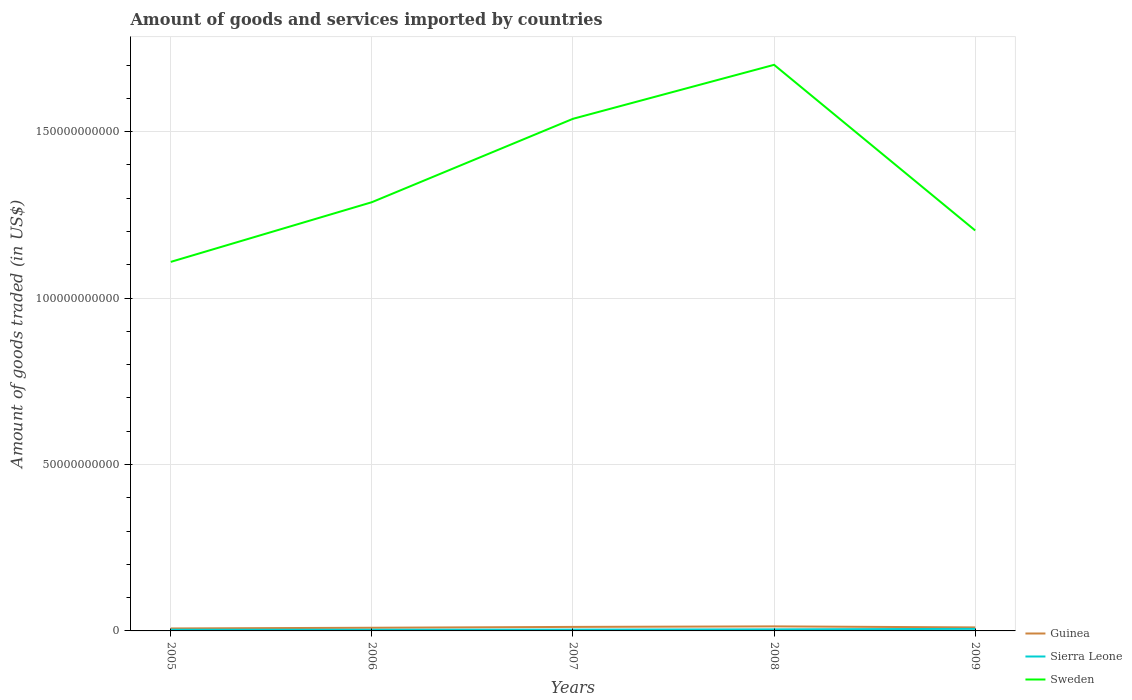How many different coloured lines are there?
Your response must be concise. 3. Does the line corresponding to Sweden intersect with the line corresponding to Guinea?
Make the answer very short. No. Is the number of lines equal to the number of legend labels?
Ensure brevity in your answer.  Yes. Across all years, what is the maximum total amount of goods and services imported in Sierra Leone?
Provide a short and direct response. 3.51e+08. In which year was the total amount of goods and services imported in Guinea maximum?
Give a very brief answer. 2005. What is the total total amount of goods and services imported in Guinea in the graph?
Keep it short and to the point. 3.10e+08. What is the difference between the highest and the second highest total amount of goods and services imported in Sweden?
Make the answer very short. 5.92e+1. What is the difference between the highest and the lowest total amount of goods and services imported in Guinea?
Your answer should be very brief. 2. Is the total amount of goods and services imported in Sweden strictly greater than the total amount of goods and services imported in Sierra Leone over the years?
Offer a terse response. No. What is the difference between two consecutive major ticks on the Y-axis?
Offer a very short reply. 5.00e+1. Does the graph contain any zero values?
Give a very brief answer. No. Does the graph contain grids?
Provide a succinct answer. Yes. Where does the legend appear in the graph?
Make the answer very short. Bottom right. How many legend labels are there?
Provide a short and direct response. 3. What is the title of the graph?
Ensure brevity in your answer.  Amount of goods and services imported by countries. What is the label or title of the Y-axis?
Offer a very short reply. Amount of goods traded (in US$). What is the Amount of goods traded (in US$) in Guinea in 2005?
Provide a succinct answer. 7.40e+08. What is the Amount of goods traded (in US$) of Sierra Leone in 2005?
Offer a terse response. 3.62e+08. What is the Amount of goods traded (in US$) in Sweden in 2005?
Your answer should be very brief. 1.11e+11. What is the Amount of goods traded (in US$) of Guinea in 2006?
Make the answer very short. 9.51e+08. What is the Amount of goods traded (in US$) of Sierra Leone in 2006?
Make the answer very short. 3.51e+08. What is the Amount of goods traded (in US$) of Sweden in 2006?
Your answer should be compact. 1.29e+11. What is the Amount of goods traded (in US$) of Guinea in 2007?
Ensure brevity in your answer.  1.21e+09. What is the Amount of goods traded (in US$) of Sierra Leone in 2007?
Ensure brevity in your answer.  3.95e+08. What is the Amount of goods traded (in US$) of Sweden in 2007?
Keep it short and to the point. 1.54e+11. What is the Amount of goods traded (in US$) in Guinea in 2008?
Offer a terse response. 1.36e+09. What is the Amount of goods traded (in US$) of Sierra Leone in 2008?
Give a very brief answer. 4.71e+08. What is the Amount of goods traded (in US$) of Sweden in 2008?
Provide a succinct answer. 1.70e+11. What is the Amount of goods traded (in US$) of Guinea in 2009?
Ensure brevity in your answer.  1.05e+09. What is the Amount of goods traded (in US$) of Sierra Leone in 2009?
Your answer should be compact. 6.18e+08. What is the Amount of goods traded (in US$) of Sweden in 2009?
Your answer should be compact. 1.20e+11. Across all years, what is the maximum Amount of goods traded (in US$) of Guinea?
Offer a very short reply. 1.36e+09. Across all years, what is the maximum Amount of goods traded (in US$) in Sierra Leone?
Ensure brevity in your answer.  6.18e+08. Across all years, what is the maximum Amount of goods traded (in US$) in Sweden?
Give a very brief answer. 1.70e+11. Across all years, what is the minimum Amount of goods traded (in US$) of Guinea?
Give a very brief answer. 7.40e+08. Across all years, what is the minimum Amount of goods traded (in US$) in Sierra Leone?
Offer a very short reply. 3.51e+08. Across all years, what is the minimum Amount of goods traded (in US$) of Sweden?
Your answer should be very brief. 1.11e+11. What is the total Amount of goods traded (in US$) in Guinea in the graph?
Provide a succinct answer. 5.32e+09. What is the total Amount of goods traded (in US$) in Sierra Leone in the graph?
Your answer should be compact. 2.20e+09. What is the total Amount of goods traded (in US$) in Sweden in the graph?
Keep it short and to the point. 6.84e+11. What is the difference between the Amount of goods traded (in US$) of Guinea in 2005 and that in 2006?
Provide a succinct answer. -2.11e+08. What is the difference between the Amount of goods traded (in US$) in Sierra Leone in 2005 and that in 2006?
Your answer should be very brief. 1.05e+07. What is the difference between the Amount of goods traded (in US$) in Sweden in 2005 and that in 2006?
Provide a short and direct response. -1.79e+1. What is the difference between the Amount of goods traded (in US$) in Guinea in 2005 and that in 2007?
Your answer should be compact. -4.67e+08. What is the difference between the Amount of goods traded (in US$) of Sierra Leone in 2005 and that in 2007?
Make the answer very short. -3.38e+07. What is the difference between the Amount of goods traded (in US$) in Sweden in 2005 and that in 2007?
Offer a very short reply. -4.30e+1. What is the difference between the Amount of goods traded (in US$) in Guinea in 2005 and that in 2008?
Provide a short and direct response. -6.25e+08. What is the difference between the Amount of goods traded (in US$) of Sierra Leone in 2005 and that in 2008?
Your answer should be very brief. -1.10e+08. What is the difference between the Amount of goods traded (in US$) of Sweden in 2005 and that in 2008?
Provide a succinct answer. -5.92e+1. What is the difference between the Amount of goods traded (in US$) of Guinea in 2005 and that in 2009?
Provide a succinct answer. -3.15e+08. What is the difference between the Amount of goods traded (in US$) in Sierra Leone in 2005 and that in 2009?
Your answer should be very brief. -2.56e+08. What is the difference between the Amount of goods traded (in US$) in Sweden in 2005 and that in 2009?
Offer a terse response. -9.44e+09. What is the difference between the Amount of goods traded (in US$) in Guinea in 2006 and that in 2007?
Your answer should be very brief. -2.56e+08. What is the difference between the Amount of goods traded (in US$) in Sierra Leone in 2006 and that in 2007?
Make the answer very short. -4.43e+07. What is the difference between the Amount of goods traded (in US$) of Sweden in 2006 and that in 2007?
Give a very brief answer. -2.51e+1. What is the difference between the Amount of goods traded (in US$) of Guinea in 2006 and that in 2008?
Offer a very short reply. -4.14e+08. What is the difference between the Amount of goods traded (in US$) of Sierra Leone in 2006 and that in 2008?
Provide a succinct answer. -1.20e+08. What is the difference between the Amount of goods traded (in US$) of Sweden in 2006 and that in 2008?
Ensure brevity in your answer.  -4.13e+1. What is the difference between the Amount of goods traded (in US$) in Guinea in 2006 and that in 2009?
Provide a short and direct response. -1.04e+08. What is the difference between the Amount of goods traded (in US$) of Sierra Leone in 2006 and that in 2009?
Offer a very short reply. -2.66e+08. What is the difference between the Amount of goods traded (in US$) of Sweden in 2006 and that in 2009?
Keep it short and to the point. 8.50e+09. What is the difference between the Amount of goods traded (in US$) of Guinea in 2007 and that in 2008?
Keep it short and to the point. -1.58e+08. What is the difference between the Amount of goods traded (in US$) of Sierra Leone in 2007 and that in 2008?
Your answer should be very brief. -7.58e+07. What is the difference between the Amount of goods traded (in US$) in Sweden in 2007 and that in 2008?
Offer a very short reply. -1.62e+1. What is the difference between the Amount of goods traded (in US$) in Guinea in 2007 and that in 2009?
Provide a short and direct response. 1.52e+08. What is the difference between the Amount of goods traded (in US$) in Sierra Leone in 2007 and that in 2009?
Give a very brief answer. -2.22e+08. What is the difference between the Amount of goods traded (in US$) of Sweden in 2007 and that in 2009?
Give a very brief answer. 3.36e+1. What is the difference between the Amount of goods traded (in US$) of Guinea in 2008 and that in 2009?
Your response must be concise. 3.10e+08. What is the difference between the Amount of goods traded (in US$) in Sierra Leone in 2008 and that in 2009?
Your response must be concise. -1.46e+08. What is the difference between the Amount of goods traded (in US$) of Sweden in 2008 and that in 2009?
Keep it short and to the point. 4.98e+1. What is the difference between the Amount of goods traded (in US$) of Guinea in 2005 and the Amount of goods traded (in US$) of Sierra Leone in 2006?
Provide a short and direct response. 3.88e+08. What is the difference between the Amount of goods traded (in US$) in Guinea in 2005 and the Amount of goods traded (in US$) in Sweden in 2006?
Provide a short and direct response. -1.28e+11. What is the difference between the Amount of goods traded (in US$) of Sierra Leone in 2005 and the Amount of goods traded (in US$) of Sweden in 2006?
Make the answer very short. -1.28e+11. What is the difference between the Amount of goods traded (in US$) in Guinea in 2005 and the Amount of goods traded (in US$) in Sierra Leone in 2007?
Make the answer very short. 3.44e+08. What is the difference between the Amount of goods traded (in US$) in Guinea in 2005 and the Amount of goods traded (in US$) in Sweden in 2007?
Your answer should be very brief. -1.53e+11. What is the difference between the Amount of goods traded (in US$) of Sierra Leone in 2005 and the Amount of goods traded (in US$) of Sweden in 2007?
Keep it short and to the point. -1.53e+11. What is the difference between the Amount of goods traded (in US$) in Guinea in 2005 and the Amount of goods traded (in US$) in Sierra Leone in 2008?
Your response must be concise. 2.68e+08. What is the difference between the Amount of goods traded (in US$) in Guinea in 2005 and the Amount of goods traded (in US$) in Sweden in 2008?
Offer a terse response. -1.69e+11. What is the difference between the Amount of goods traded (in US$) of Sierra Leone in 2005 and the Amount of goods traded (in US$) of Sweden in 2008?
Keep it short and to the point. -1.70e+11. What is the difference between the Amount of goods traded (in US$) in Guinea in 2005 and the Amount of goods traded (in US$) in Sierra Leone in 2009?
Offer a terse response. 1.22e+08. What is the difference between the Amount of goods traded (in US$) of Guinea in 2005 and the Amount of goods traded (in US$) of Sweden in 2009?
Make the answer very short. -1.20e+11. What is the difference between the Amount of goods traded (in US$) in Sierra Leone in 2005 and the Amount of goods traded (in US$) in Sweden in 2009?
Offer a terse response. -1.20e+11. What is the difference between the Amount of goods traded (in US$) in Guinea in 2006 and the Amount of goods traded (in US$) in Sierra Leone in 2007?
Offer a terse response. 5.55e+08. What is the difference between the Amount of goods traded (in US$) in Guinea in 2006 and the Amount of goods traded (in US$) in Sweden in 2007?
Make the answer very short. -1.53e+11. What is the difference between the Amount of goods traded (in US$) of Sierra Leone in 2006 and the Amount of goods traded (in US$) of Sweden in 2007?
Give a very brief answer. -1.53e+11. What is the difference between the Amount of goods traded (in US$) of Guinea in 2006 and the Amount of goods traded (in US$) of Sierra Leone in 2008?
Give a very brief answer. 4.79e+08. What is the difference between the Amount of goods traded (in US$) of Guinea in 2006 and the Amount of goods traded (in US$) of Sweden in 2008?
Your answer should be very brief. -1.69e+11. What is the difference between the Amount of goods traded (in US$) in Sierra Leone in 2006 and the Amount of goods traded (in US$) in Sweden in 2008?
Keep it short and to the point. -1.70e+11. What is the difference between the Amount of goods traded (in US$) of Guinea in 2006 and the Amount of goods traded (in US$) of Sierra Leone in 2009?
Your answer should be compact. 3.33e+08. What is the difference between the Amount of goods traded (in US$) of Guinea in 2006 and the Amount of goods traded (in US$) of Sweden in 2009?
Your answer should be compact. -1.19e+11. What is the difference between the Amount of goods traded (in US$) in Sierra Leone in 2006 and the Amount of goods traded (in US$) in Sweden in 2009?
Give a very brief answer. -1.20e+11. What is the difference between the Amount of goods traded (in US$) in Guinea in 2007 and the Amount of goods traded (in US$) in Sierra Leone in 2008?
Your answer should be very brief. 7.35e+08. What is the difference between the Amount of goods traded (in US$) of Guinea in 2007 and the Amount of goods traded (in US$) of Sweden in 2008?
Provide a succinct answer. -1.69e+11. What is the difference between the Amount of goods traded (in US$) in Sierra Leone in 2007 and the Amount of goods traded (in US$) in Sweden in 2008?
Your answer should be very brief. -1.70e+11. What is the difference between the Amount of goods traded (in US$) in Guinea in 2007 and the Amount of goods traded (in US$) in Sierra Leone in 2009?
Your response must be concise. 5.89e+08. What is the difference between the Amount of goods traded (in US$) in Guinea in 2007 and the Amount of goods traded (in US$) in Sweden in 2009?
Provide a succinct answer. -1.19e+11. What is the difference between the Amount of goods traded (in US$) of Sierra Leone in 2007 and the Amount of goods traded (in US$) of Sweden in 2009?
Ensure brevity in your answer.  -1.20e+11. What is the difference between the Amount of goods traded (in US$) in Guinea in 2008 and the Amount of goods traded (in US$) in Sierra Leone in 2009?
Your answer should be very brief. 7.47e+08. What is the difference between the Amount of goods traded (in US$) in Guinea in 2008 and the Amount of goods traded (in US$) in Sweden in 2009?
Offer a terse response. -1.19e+11. What is the difference between the Amount of goods traded (in US$) of Sierra Leone in 2008 and the Amount of goods traded (in US$) of Sweden in 2009?
Provide a short and direct response. -1.20e+11. What is the average Amount of goods traded (in US$) in Guinea per year?
Provide a succinct answer. 1.06e+09. What is the average Amount of goods traded (in US$) of Sierra Leone per year?
Offer a terse response. 4.39e+08. What is the average Amount of goods traded (in US$) of Sweden per year?
Your answer should be compact. 1.37e+11. In the year 2005, what is the difference between the Amount of goods traded (in US$) in Guinea and Amount of goods traded (in US$) in Sierra Leone?
Give a very brief answer. 3.78e+08. In the year 2005, what is the difference between the Amount of goods traded (in US$) of Guinea and Amount of goods traded (in US$) of Sweden?
Ensure brevity in your answer.  -1.10e+11. In the year 2005, what is the difference between the Amount of goods traded (in US$) in Sierra Leone and Amount of goods traded (in US$) in Sweden?
Provide a short and direct response. -1.10e+11. In the year 2006, what is the difference between the Amount of goods traded (in US$) in Guinea and Amount of goods traded (in US$) in Sierra Leone?
Offer a terse response. 5.99e+08. In the year 2006, what is the difference between the Amount of goods traded (in US$) in Guinea and Amount of goods traded (in US$) in Sweden?
Keep it short and to the point. -1.28e+11. In the year 2006, what is the difference between the Amount of goods traded (in US$) in Sierra Leone and Amount of goods traded (in US$) in Sweden?
Your answer should be compact. -1.28e+11. In the year 2007, what is the difference between the Amount of goods traded (in US$) of Guinea and Amount of goods traded (in US$) of Sierra Leone?
Ensure brevity in your answer.  8.11e+08. In the year 2007, what is the difference between the Amount of goods traded (in US$) of Guinea and Amount of goods traded (in US$) of Sweden?
Provide a short and direct response. -1.53e+11. In the year 2007, what is the difference between the Amount of goods traded (in US$) in Sierra Leone and Amount of goods traded (in US$) in Sweden?
Keep it short and to the point. -1.53e+11. In the year 2008, what is the difference between the Amount of goods traded (in US$) of Guinea and Amount of goods traded (in US$) of Sierra Leone?
Provide a short and direct response. 8.93e+08. In the year 2008, what is the difference between the Amount of goods traded (in US$) in Guinea and Amount of goods traded (in US$) in Sweden?
Give a very brief answer. -1.69e+11. In the year 2008, what is the difference between the Amount of goods traded (in US$) of Sierra Leone and Amount of goods traded (in US$) of Sweden?
Keep it short and to the point. -1.70e+11. In the year 2009, what is the difference between the Amount of goods traded (in US$) of Guinea and Amount of goods traded (in US$) of Sierra Leone?
Provide a succinct answer. 4.37e+08. In the year 2009, what is the difference between the Amount of goods traded (in US$) in Guinea and Amount of goods traded (in US$) in Sweden?
Your answer should be compact. -1.19e+11. In the year 2009, what is the difference between the Amount of goods traded (in US$) in Sierra Leone and Amount of goods traded (in US$) in Sweden?
Ensure brevity in your answer.  -1.20e+11. What is the ratio of the Amount of goods traded (in US$) in Guinea in 2005 to that in 2006?
Your response must be concise. 0.78. What is the ratio of the Amount of goods traded (in US$) of Sierra Leone in 2005 to that in 2006?
Provide a short and direct response. 1.03. What is the ratio of the Amount of goods traded (in US$) of Sweden in 2005 to that in 2006?
Keep it short and to the point. 0.86. What is the ratio of the Amount of goods traded (in US$) in Guinea in 2005 to that in 2007?
Keep it short and to the point. 0.61. What is the ratio of the Amount of goods traded (in US$) of Sierra Leone in 2005 to that in 2007?
Your answer should be very brief. 0.91. What is the ratio of the Amount of goods traded (in US$) in Sweden in 2005 to that in 2007?
Your answer should be very brief. 0.72. What is the ratio of the Amount of goods traded (in US$) of Guinea in 2005 to that in 2008?
Provide a succinct answer. 0.54. What is the ratio of the Amount of goods traded (in US$) in Sierra Leone in 2005 to that in 2008?
Your answer should be very brief. 0.77. What is the ratio of the Amount of goods traded (in US$) of Sweden in 2005 to that in 2008?
Provide a succinct answer. 0.65. What is the ratio of the Amount of goods traded (in US$) in Guinea in 2005 to that in 2009?
Provide a short and direct response. 0.7. What is the ratio of the Amount of goods traded (in US$) of Sierra Leone in 2005 to that in 2009?
Ensure brevity in your answer.  0.59. What is the ratio of the Amount of goods traded (in US$) of Sweden in 2005 to that in 2009?
Your answer should be compact. 0.92. What is the ratio of the Amount of goods traded (in US$) in Guinea in 2006 to that in 2007?
Make the answer very short. 0.79. What is the ratio of the Amount of goods traded (in US$) of Sierra Leone in 2006 to that in 2007?
Give a very brief answer. 0.89. What is the ratio of the Amount of goods traded (in US$) in Sweden in 2006 to that in 2007?
Your answer should be compact. 0.84. What is the ratio of the Amount of goods traded (in US$) in Guinea in 2006 to that in 2008?
Ensure brevity in your answer.  0.7. What is the ratio of the Amount of goods traded (in US$) in Sierra Leone in 2006 to that in 2008?
Ensure brevity in your answer.  0.75. What is the ratio of the Amount of goods traded (in US$) in Sweden in 2006 to that in 2008?
Offer a very short reply. 0.76. What is the ratio of the Amount of goods traded (in US$) of Guinea in 2006 to that in 2009?
Your response must be concise. 0.9. What is the ratio of the Amount of goods traded (in US$) in Sierra Leone in 2006 to that in 2009?
Provide a succinct answer. 0.57. What is the ratio of the Amount of goods traded (in US$) of Sweden in 2006 to that in 2009?
Offer a very short reply. 1.07. What is the ratio of the Amount of goods traded (in US$) of Guinea in 2007 to that in 2008?
Ensure brevity in your answer.  0.88. What is the ratio of the Amount of goods traded (in US$) of Sierra Leone in 2007 to that in 2008?
Make the answer very short. 0.84. What is the ratio of the Amount of goods traded (in US$) in Sweden in 2007 to that in 2008?
Your answer should be compact. 0.9. What is the ratio of the Amount of goods traded (in US$) of Guinea in 2007 to that in 2009?
Your answer should be very brief. 1.14. What is the ratio of the Amount of goods traded (in US$) of Sierra Leone in 2007 to that in 2009?
Provide a succinct answer. 0.64. What is the ratio of the Amount of goods traded (in US$) of Sweden in 2007 to that in 2009?
Offer a very short reply. 1.28. What is the ratio of the Amount of goods traded (in US$) of Guinea in 2008 to that in 2009?
Provide a succinct answer. 1.29. What is the ratio of the Amount of goods traded (in US$) of Sierra Leone in 2008 to that in 2009?
Provide a succinct answer. 0.76. What is the ratio of the Amount of goods traded (in US$) in Sweden in 2008 to that in 2009?
Your answer should be very brief. 1.41. What is the difference between the highest and the second highest Amount of goods traded (in US$) of Guinea?
Ensure brevity in your answer.  1.58e+08. What is the difference between the highest and the second highest Amount of goods traded (in US$) of Sierra Leone?
Offer a very short reply. 1.46e+08. What is the difference between the highest and the second highest Amount of goods traded (in US$) in Sweden?
Give a very brief answer. 1.62e+1. What is the difference between the highest and the lowest Amount of goods traded (in US$) of Guinea?
Give a very brief answer. 6.25e+08. What is the difference between the highest and the lowest Amount of goods traded (in US$) in Sierra Leone?
Give a very brief answer. 2.66e+08. What is the difference between the highest and the lowest Amount of goods traded (in US$) in Sweden?
Your response must be concise. 5.92e+1. 